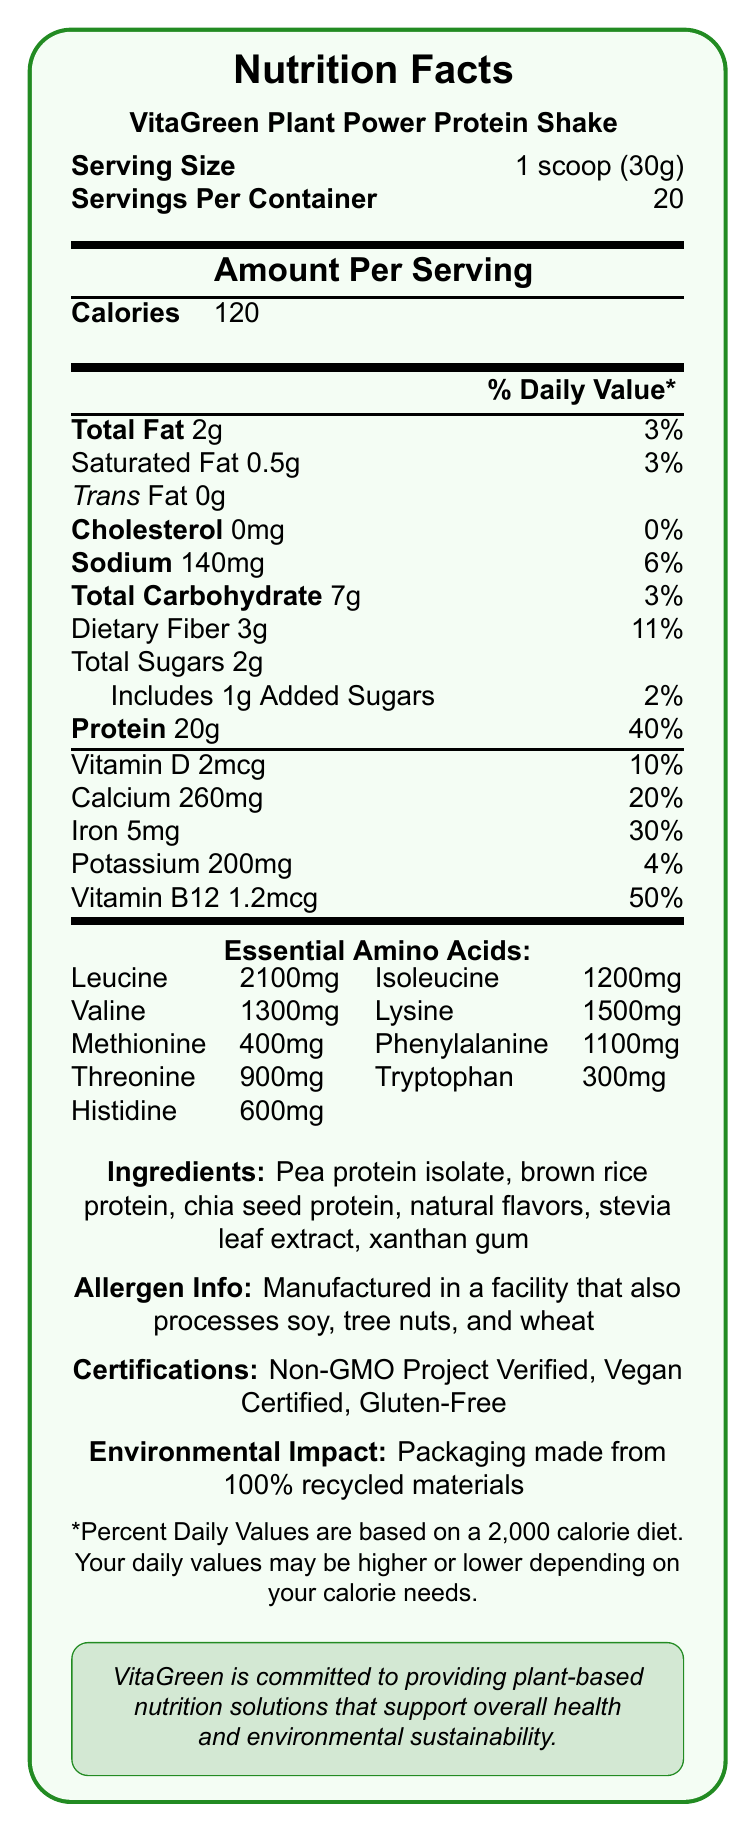What is the serving size for VitaGreen Plant Power Protein Shake? The serving size is explicitly mentioned in the Nutrition Facts Label as "1 scoop (30g)".
Answer: 1 scoop (30g) How many calories are there per serving? The amount per serving for calories is listed as 120 in the Nutrition Facts Label.
Answer: 120 How much protein does one serving of the protein shake contain? The protein content per serving is specified as 20g in the Nutrition Facts Label.
Answer: 20g List the certifications for VitaGreen Plant Power Protein Shake. The certifications are clearly listed at the bottom of the document.
Answer: Non-GMO Project Verified, Vegan Certified, Gluten-Free Does the product contain any cholesterol? The Nutrition Facts Label specifies "Cholesterol 0mg", indicating there is no cholesterol.
Answer: No Which essential amino acid is present in the highest quantity? Leucine is listed with the highest amount at 2100mg among the essential amino acids.
Answer: Leucine How much Vitamin B12 is in one serving, and what percentage of the daily value does it represent? The document states 1.2mcg of Vitamin B12, which represents 50% of the daily value.
Answer: 1.2mcg, 50% What is the main mission of VitaGreen? The mission statement is located at the bottom of the document, inside a boxed section.
Answer: Providing plant-based nutrition solutions that support overall health and environmental sustainability What are the three types of proteins included in the ingredients? These three proteins are listed in the ingredients section of the document.
Answer: Pea protein isolate, brown rice protein, chia seed protein Which essential amino acid has the lowest quantity listed in the document? Tryptophan has the lowest quantity listed among the essential amino acids at 300mg.
Answer: Tryptophan How many servings are there in one container? The number of servings per container is specified as 20 in the document.
Answer: 20 What percentage of the daily value of iron does one serving provide? A. 10% B. 20% C. 30% D. 40% The document shows that one serving provides 30% of the daily value of iron.
Answer: C Which of the following amino acids are present in quantities greater than 1000mg per serving? (Select all that apply) i. Leucine ii. Lysine iii. Methionine iv. Phenylalanine Leucine (2100mg), Lysine (1500mg), and Phenylalanine (1100mg) are all present in quantities greater than 1000mg per serving.
Answer: i, ii, iv Is the packaging of VitaGreen Plant Power Protein Shake environmentally friendly? The document mentions that the packaging is made from 100% recycled materials, indicating environmental friendliness.
Answer: Yes Summarize the key nutritional benefits and characteristics of VitaGreen Plant Power Protein Shake. This summary includes information about protein content, essential amino acids, vitamins, certifications, and environmental impact as detailed in the document.
Answer: VitaGreen Plant Power Protein Shake offers 20g of protein per serving, which is 40% of the daily value. It contains essential amino acids, is rich in iron and Vitamin B12, and is certified Non-GMO, Vegan, and Gluten-Free. The product is packaged in 100% recycled materials, emphasizing environmental sustainability. What is the total carbohydrate content, including dietary fiber and total sugars, per serving? The total carbohydrate content is shown as 7g, with dietary fiber at 3g and total sugars at 2g.
Answer: 7g, 3g dietary fiber, 2g total sugars What are "natural flavors" in the ingredients referring to? The document lists "natural flavors" in the ingredients but does not provide detailed information about what specific flavors are included.
Answer: Not enough information 